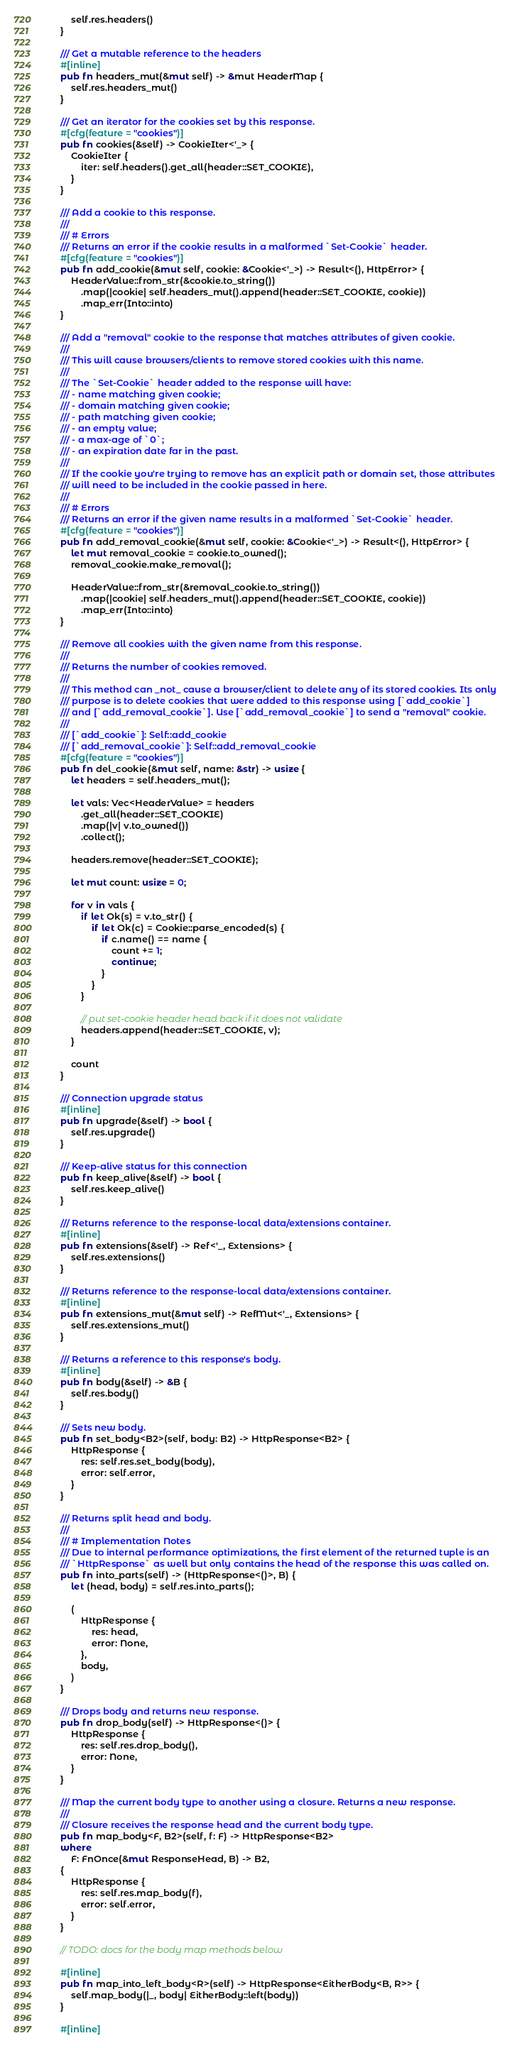<code> <loc_0><loc_0><loc_500><loc_500><_Rust_>        self.res.headers()
    }

    /// Get a mutable reference to the headers
    #[inline]
    pub fn headers_mut(&mut self) -> &mut HeaderMap {
        self.res.headers_mut()
    }

    /// Get an iterator for the cookies set by this response.
    #[cfg(feature = "cookies")]
    pub fn cookies(&self) -> CookieIter<'_> {
        CookieIter {
            iter: self.headers().get_all(header::SET_COOKIE),
        }
    }

    /// Add a cookie to this response.
    ///
    /// # Errors
    /// Returns an error if the cookie results in a malformed `Set-Cookie` header.
    #[cfg(feature = "cookies")]
    pub fn add_cookie(&mut self, cookie: &Cookie<'_>) -> Result<(), HttpError> {
        HeaderValue::from_str(&cookie.to_string())
            .map(|cookie| self.headers_mut().append(header::SET_COOKIE, cookie))
            .map_err(Into::into)
    }

    /// Add a "removal" cookie to the response that matches attributes of given cookie.
    ///
    /// This will cause browsers/clients to remove stored cookies with this name.
    ///
    /// The `Set-Cookie` header added to the response will have:
    /// - name matching given cookie;
    /// - domain matching given cookie;
    /// - path matching given cookie;
    /// - an empty value;
    /// - a max-age of `0`;
    /// - an expiration date far in the past.
    ///
    /// If the cookie you're trying to remove has an explicit path or domain set, those attributes
    /// will need to be included in the cookie passed in here.
    ///
    /// # Errors
    /// Returns an error if the given name results in a malformed `Set-Cookie` header.
    #[cfg(feature = "cookies")]
    pub fn add_removal_cookie(&mut self, cookie: &Cookie<'_>) -> Result<(), HttpError> {
        let mut removal_cookie = cookie.to_owned();
        removal_cookie.make_removal();

        HeaderValue::from_str(&removal_cookie.to_string())
            .map(|cookie| self.headers_mut().append(header::SET_COOKIE, cookie))
            .map_err(Into::into)
    }

    /// Remove all cookies with the given name from this response.
    ///
    /// Returns the number of cookies removed.
    ///
    /// This method can _not_ cause a browser/client to delete any of its stored cookies. Its only
    /// purpose is to delete cookies that were added to this response using [`add_cookie`]
    /// and [`add_removal_cookie`]. Use [`add_removal_cookie`] to send a "removal" cookie.
    ///
    /// [`add_cookie`]: Self::add_cookie
    /// [`add_removal_cookie`]: Self::add_removal_cookie
    #[cfg(feature = "cookies")]
    pub fn del_cookie(&mut self, name: &str) -> usize {
        let headers = self.headers_mut();

        let vals: Vec<HeaderValue> = headers
            .get_all(header::SET_COOKIE)
            .map(|v| v.to_owned())
            .collect();

        headers.remove(header::SET_COOKIE);

        let mut count: usize = 0;

        for v in vals {
            if let Ok(s) = v.to_str() {
                if let Ok(c) = Cookie::parse_encoded(s) {
                    if c.name() == name {
                        count += 1;
                        continue;
                    }
                }
            }

            // put set-cookie header head back if it does not validate
            headers.append(header::SET_COOKIE, v);
        }

        count
    }

    /// Connection upgrade status
    #[inline]
    pub fn upgrade(&self) -> bool {
        self.res.upgrade()
    }

    /// Keep-alive status for this connection
    pub fn keep_alive(&self) -> bool {
        self.res.keep_alive()
    }

    /// Returns reference to the response-local data/extensions container.
    #[inline]
    pub fn extensions(&self) -> Ref<'_, Extensions> {
        self.res.extensions()
    }

    /// Returns reference to the response-local data/extensions container.
    #[inline]
    pub fn extensions_mut(&mut self) -> RefMut<'_, Extensions> {
        self.res.extensions_mut()
    }

    /// Returns a reference to this response's body.
    #[inline]
    pub fn body(&self) -> &B {
        self.res.body()
    }

    /// Sets new body.
    pub fn set_body<B2>(self, body: B2) -> HttpResponse<B2> {
        HttpResponse {
            res: self.res.set_body(body),
            error: self.error,
        }
    }

    /// Returns split head and body.
    ///
    /// # Implementation Notes
    /// Due to internal performance optimizations, the first element of the returned tuple is an
    /// `HttpResponse` as well but only contains the head of the response this was called on.
    pub fn into_parts(self) -> (HttpResponse<()>, B) {
        let (head, body) = self.res.into_parts();

        (
            HttpResponse {
                res: head,
                error: None,
            },
            body,
        )
    }

    /// Drops body and returns new response.
    pub fn drop_body(self) -> HttpResponse<()> {
        HttpResponse {
            res: self.res.drop_body(),
            error: None,
        }
    }

    /// Map the current body type to another using a closure. Returns a new response.
    ///
    /// Closure receives the response head and the current body type.
    pub fn map_body<F, B2>(self, f: F) -> HttpResponse<B2>
    where
        F: FnOnce(&mut ResponseHead, B) -> B2,
    {
        HttpResponse {
            res: self.res.map_body(f),
            error: self.error,
        }
    }

    // TODO: docs for the body map methods below

    #[inline]
    pub fn map_into_left_body<R>(self) -> HttpResponse<EitherBody<B, R>> {
        self.map_body(|_, body| EitherBody::left(body))
    }

    #[inline]</code> 